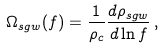<formula> <loc_0><loc_0><loc_500><loc_500>\Omega _ { s g w } ( f ) = \frac { 1 } { \rho _ { c } } \frac { d \rho _ { s g w } } { d \ln f } \, ,</formula> 